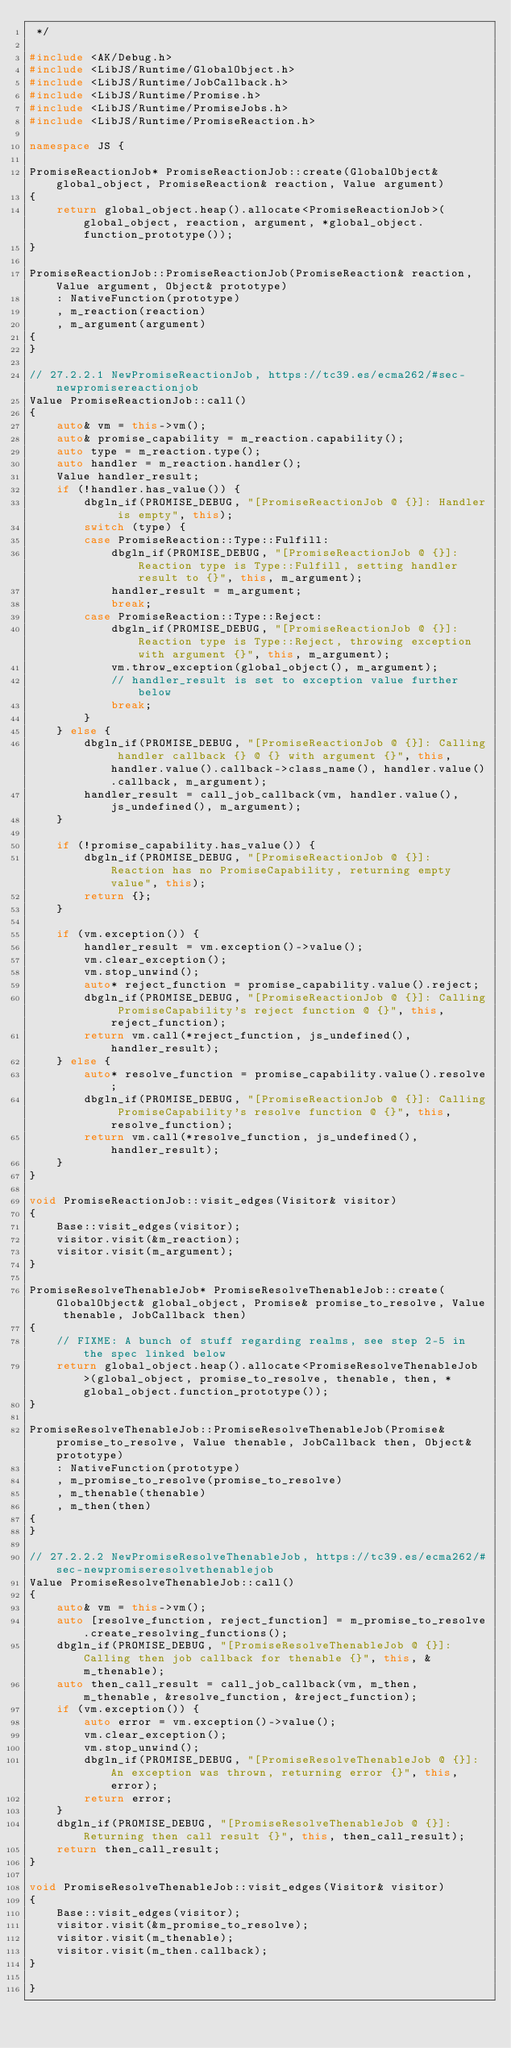<code> <loc_0><loc_0><loc_500><loc_500><_C++_> */

#include <AK/Debug.h>
#include <LibJS/Runtime/GlobalObject.h>
#include <LibJS/Runtime/JobCallback.h>
#include <LibJS/Runtime/Promise.h>
#include <LibJS/Runtime/PromiseJobs.h>
#include <LibJS/Runtime/PromiseReaction.h>

namespace JS {

PromiseReactionJob* PromiseReactionJob::create(GlobalObject& global_object, PromiseReaction& reaction, Value argument)
{
    return global_object.heap().allocate<PromiseReactionJob>(global_object, reaction, argument, *global_object.function_prototype());
}

PromiseReactionJob::PromiseReactionJob(PromiseReaction& reaction, Value argument, Object& prototype)
    : NativeFunction(prototype)
    , m_reaction(reaction)
    , m_argument(argument)
{
}

// 27.2.2.1 NewPromiseReactionJob, https://tc39.es/ecma262/#sec-newpromisereactionjob
Value PromiseReactionJob::call()
{
    auto& vm = this->vm();
    auto& promise_capability = m_reaction.capability();
    auto type = m_reaction.type();
    auto handler = m_reaction.handler();
    Value handler_result;
    if (!handler.has_value()) {
        dbgln_if(PROMISE_DEBUG, "[PromiseReactionJob @ {}]: Handler is empty", this);
        switch (type) {
        case PromiseReaction::Type::Fulfill:
            dbgln_if(PROMISE_DEBUG, "[PromiseReactionJob @ {}]: Reaction type is Type::Fulfill, setting handler result to {}", this, m_argument);
            handler_result = m_argument;
            break;
        case PromiseReaction::Type::Reject:
            dbgln_if(PROMISE_DEBUG, "[PromiseReactionJob @ {}]: Reaction type is Type::Reject, throwing exception with argument {}", this, m_argument);
            vm.throw_exception(global_object(), m_argument);
            // handler_result is set to exception value further below
            break;
        }
    } else {
        dbgln_if(PROMISE_DEBUG, "[PromiseReactionJob @ {}]: Calling handler callback {} @ {} with argument {}", this, handler.value().callback->class_name(), handler.value().callback, m_argument);
        handler_result = call_job_callback(vm, handler.value(), js_undefined(), m_argument);
    }

    if (!promise_capability.has_value()) {
        dbgln_if(PROMISE_DEBUG, "[PromiseReactionJob @ {}]: Reaction has no PromiseCapability, returning empty value", this);
        return {};
    }

    if (vm.exception()) {
        handler_result = vm.exception()->value();
        vm.clear_exception();
        vm.stop_unwind();
        auto* reject_function = promise_capability.value().reject;
        dbgln_if(PROMISE_DEBUG, "[PromiseReactionJob @ {}]: Calling PromiseCapability's reject function @ {}", this, reject_function);
        return vm.call(*reject_function, js_undefined(), handler_result);
    } else {
        auto* resolve_function = promise_capability.value().resolve;
        dbgln_if(PROMISE_DEBUG, "[PromiseReactionJob @ {}]: Calling PromiseCapability's resolve function @ {}", this, resolve_function);
        return vm.call(*resolve_function, js_undefined(), handler_result);
    }
}

void PromiseReactionJob::visit_edges(Visitor& visitor)
{
    Base::visit_edges(visitor);
    visitor.visit(&m_reaction);
    visitor.visit(m_argument);
}

PromiseResolveThenableJob* PromiseResolveThenableJob::create(GlobalObject& global_object, Promise& promise_to_resolve, Value thenable, JobCallback then)
{
    // FIXME: A bunch of stuff regarding realms, see step 2-5 in the spec linked below
    return global_object.heap().allocate<PromiseResolveThenableJob>(global_object, promise_to_resolve, thenable, then, *global_object.function_prototype());
}

PromiseResolveThenableJob::PromiseResolveThenableJob(Promise& promise_to_resolve, Value thenable, JobCallback then, Object& prototype)
    : NativeFunction(prototype)
    , m_promise_to_resolve(promise_to_resolve)
    , m_thenable(thenable)
    , m_then(then)
{
}

// 27.2.2.2 NewPromiseResolveThenableJob, https://tc39.es/ecma262/#sec-newpromiseresolvethenablejob
Value PromiseResolveThenableJob::call()
{
    auto& vm = this->vm();
    auto [resolve_function, reject_function] = m_promise_to_resolve.create_resolving_functions();
    dbgln_if(PROMISE_DEBUG, "[PromiseResolveThenableJob @ {}]: Calling then job callback for thenable {}", this, &m_thenable);
    auto then_call_result = call_job_callback(vm, m_then, m_thenable, &resolve_function, &reject_function);
    if (vm.exception()) {
        auto error = vm.exception()->value();
        vm.clear_exception();
        vm.stop_unwind();
        dbgln_if(PROMISE_DEBUG, "[PromiseResolveThenableJob @ {}]: An exception was thrown, returning error {}", this, error);
        return error;
    }
    dbgln_if(PROMISE_DEBUG, "[PromiseResolveThenableJob @ {}]: Returning then call result {}", this, then_call_result);
    return then_call_result;
}

void PromiseResolveThenableJob::visit_edges(Visitor& visitor)
{
    Base::visit_edges(visitor);
    visitor.visit(&m_promise_to_resolve);
    visitor.visit(m_thenable);
    visitor.visit(m_then.callback);
}

}
</code> 